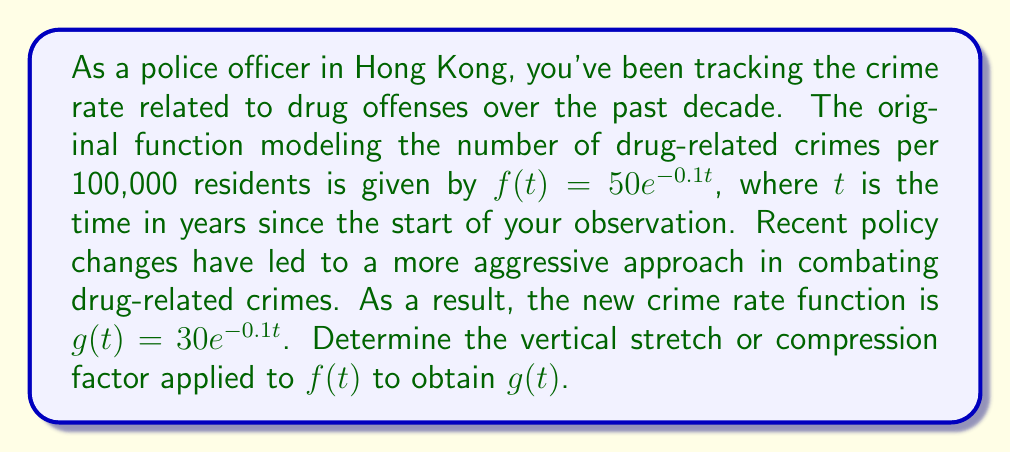Could you help me with this problem? To determine the vertical stretch or compression factor, we need to compare the new function $g(t)$ with the original function $f(t)$.

1) The original function is $f(t) = 50e^{-0.1t}$
2) The new function is $g(t) = 30e^{-0.1t}$

3) We can express $g(t)$ in terms of $f(t)$ as follows:
   $g(t) = 30e^{-0.1t} = \frac{30}{50} \cdot 50e^{-0.1t} = \frac{3}{5} \cdot 50e^{-0.1t} = \frac{3}{5}f(t)$

4) The factor $\frac{3}{5}$ is applied to $f(t)$ to obtain $g(t)$

5) Since this factor is less than 1, it represents a vertical compression

6) The compression factor is $\frac{3}{5}$ or 0.6

This means that the new function $g(t)$ is a vertical compression of $f(t)$ by a factor of $\frac{3}{5}$, indicating that the crime rate has decreased to 60% of its original value at each point in time.
Answer: The vertical compression factor is $\frac{3}{5}$ or 0.6. 